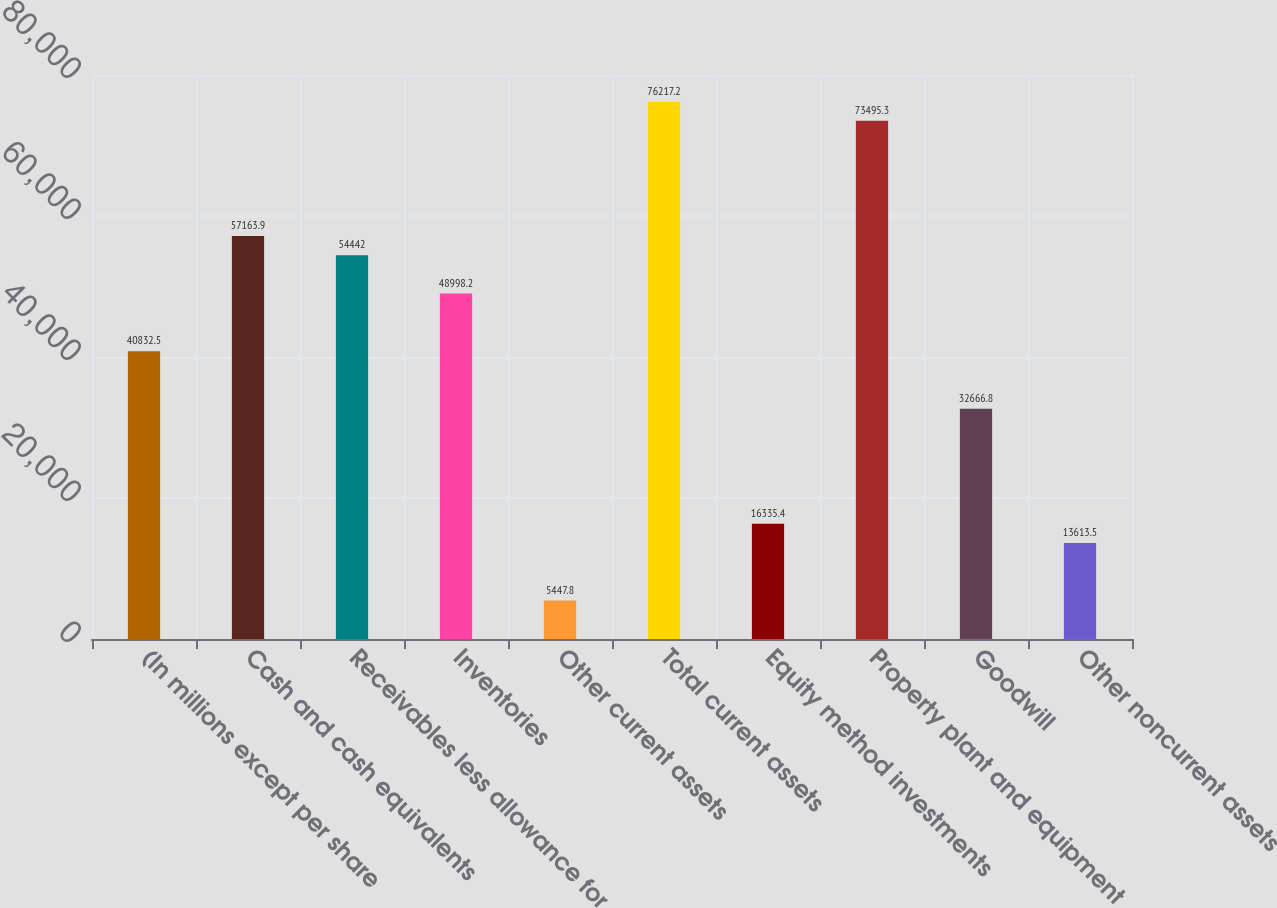<chart> <loc_0><loc_0><loc_500><loc_500><bar_chart><fcel>(In millions except per share<fcel>Cash and cash equivalents<fcel>Receivables less allowance for<fcel>Inventories<fcel>Other current assets<fcel>Total current assets<fcel>Equity method investments<fcel>Property plant and equipment<fcel>Goodwill<fcel>Other noncurrent assets<nl><fcel>40832.5<fcel>57163.9<fcel>54442<fcel>48998.2<fcel>5447.8<fcel>76217.2<fcel>16335.4<fcel>73495.3<fcel>32666.8<fcel>13613.5<nl></chart> 